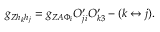Convert formula to latex. <formula><loc_0><loc_0><loc_500><loc_500>g _ { Z h _ { k } h _ { j } } = g _ { Z A \Phi _ { i } } O _ { j i } ^ { \prime } O _ { k 3 } ^ { \prime } - ( k \leftrightarrow j ) .</formula> 